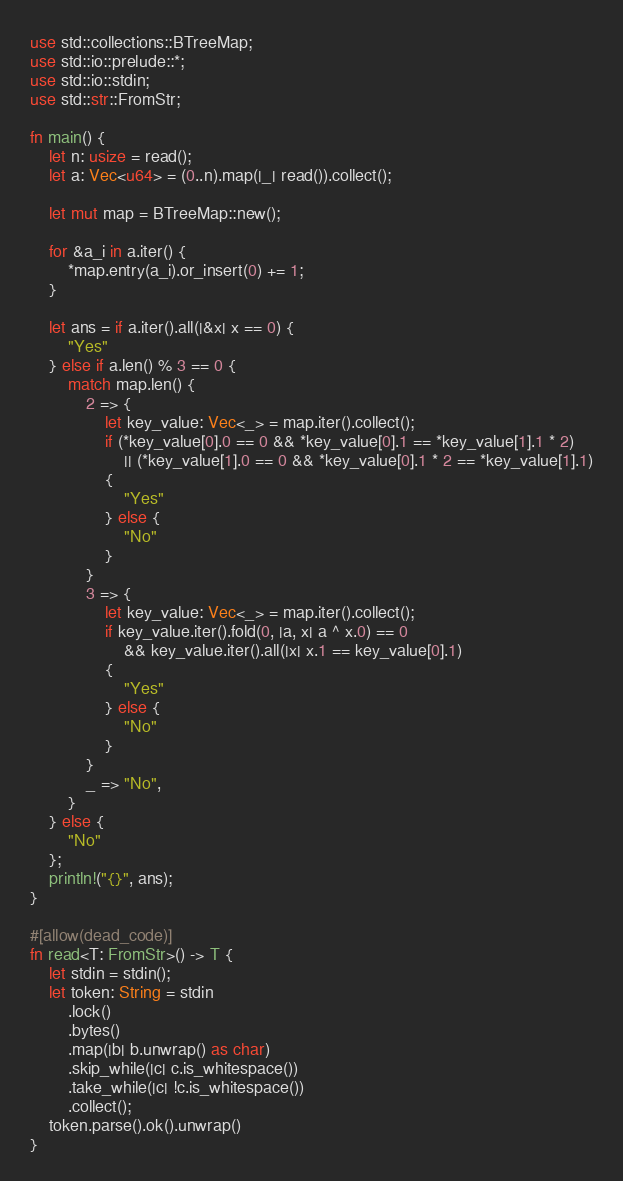Convert code to text. <code><loc_0><loc_0><loc_500><loc_500><_Rust_>use std::collections::BTreeMap;
use std::io::prelude::*;
use std::io::stdin;
use std::str::FromStr;

fn main() {
    let n: usize = read();
    let a: Vec<u64> = (0..n).map(|_| read()).collect();

    let mut map = BTreeMap::new();

    for &a_i in a.iter() {
        *map.entry(a_i).or_insert(0) += 1;
    }

    let ans = if a.iter().all(|&x| x == 0) {
        "Yes"
    } else if a.len() % 3 == 0 {
        match map.len() {
            2 => {
                let key_value: Vec<_> = map.iter().collect();
                if (*key_value[0].0 == 0 && *key_value[0].1 == *key_value[1].1 * 2)
                    || (*key_value[1].0 == 0 && *key_value[0].1 * 2 == *key_value[1].1)
                {
                    "Yes"
                } else {
                    "No"
                }
            }
            3 => {
                let key_value: Vec<_> = map.iter().collect();
                if key_value.iter().fold(0, |a, x| a ^ x.0) == 0
                    && key_value.iter().all(|x| x.1 == key_value[0].1)
                {
                    "Yes"
                } else {
                    "No"
                }
            }
            _ => "No",
        }
    } else {
        "No"
    };
    println!("{}", ans);
}

#[allow(dead_code)]
fn read<T: FromStr>() -> T {
    let stdin = stdin();
    let token: String = stdin
        .lock()
        .bytes()
        .map(|b| b.unwrap() as char)
        .skip_while(|c| c.is_whitespace())
        .take_while(|c| !c.is_whitespace())
        .collect();
    token.parse().ok().unwrap()
}
</code> 